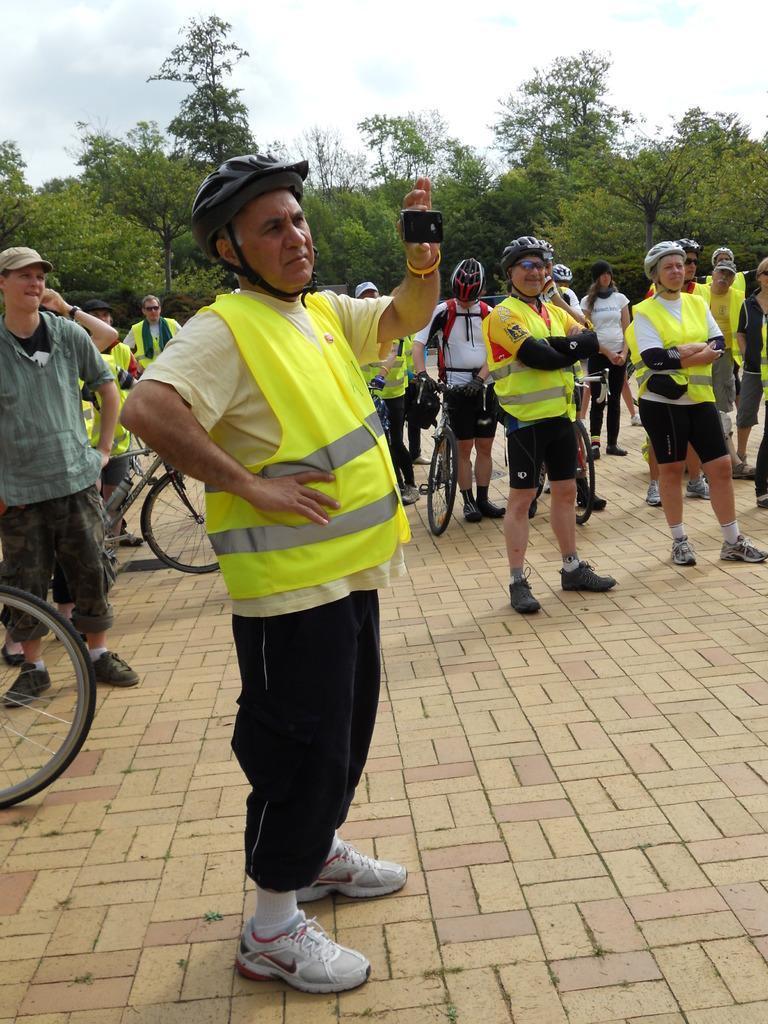In one or two sentences, can you explain what this image depicts? In this picture there are group of people. At the top there is a sky and at the back there are trees. 